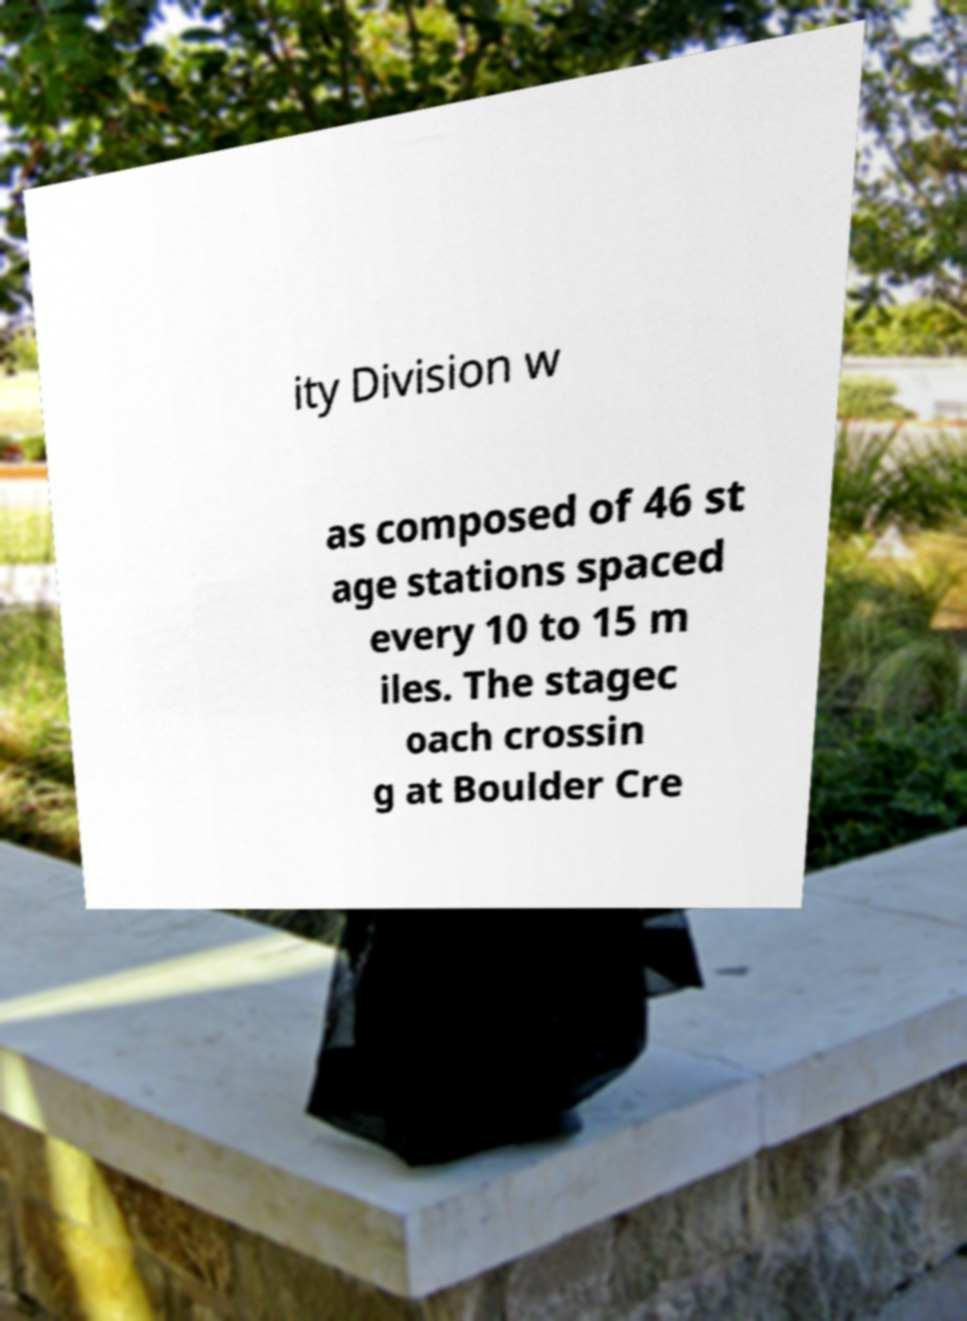What messages or text are displayed in this image? I need them in a readable, typed format. ity Division w as composed of 46 st age stations spaced every 10 to 15 m iles. The stagec oach crossin g at Boulder Cre 